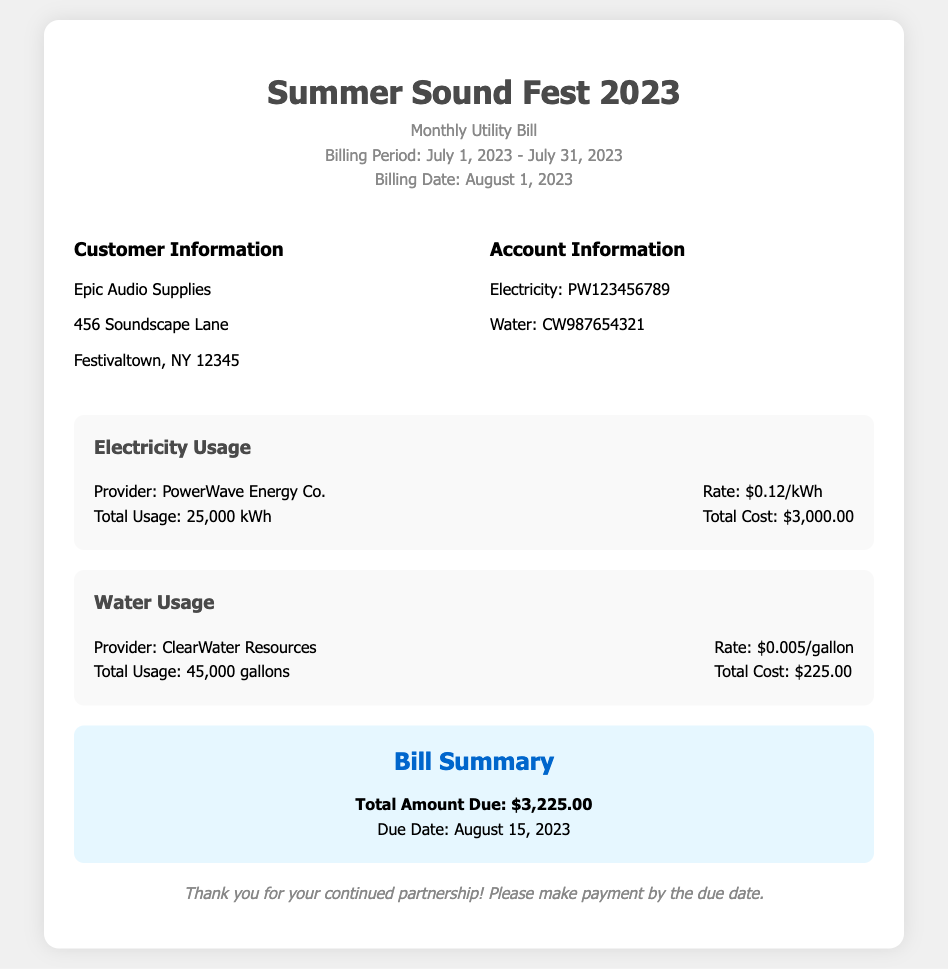what is the total electricity usage? The total electricity usage is explicitly stated in the document as 25,000 kWh.
Answer: 25,000 kWh what is the total water usage? The total water usage can be found in the water usage section and is 45,000 gallons.
Answer: 45,000 gallons what is the electricity rate per kWh? The rate for electricity is presented in the bill and is $0.12/kWh.
Answer: $0.12/kWh what is the total amount due? The total amount due for the month is provided in the summary section as $3,225.00.
Answer: $3,225.00 who is the electricity provider? The provider for electricity is specified in the utility section as PowerWave Energy Co.
Answer: PowerWave Energy Co which service has a higher total cost? By comparing total costs, electricity cost is $3,000.00 and water cost is $225.00, thus electricity cost is higher.
Answer: Electricity when is the due date for payment? The due date for payment is found in the summary section and is August 15, 2023.
Answer: August 15, 2023 what is the provider of water service? The provider for water is mentioned in the utility section as ClearWater Resources.
Answer: ClearWater Resources what is the total cost for water? The total cost for water is given in the document as $225.00.
Answer: $225.00 